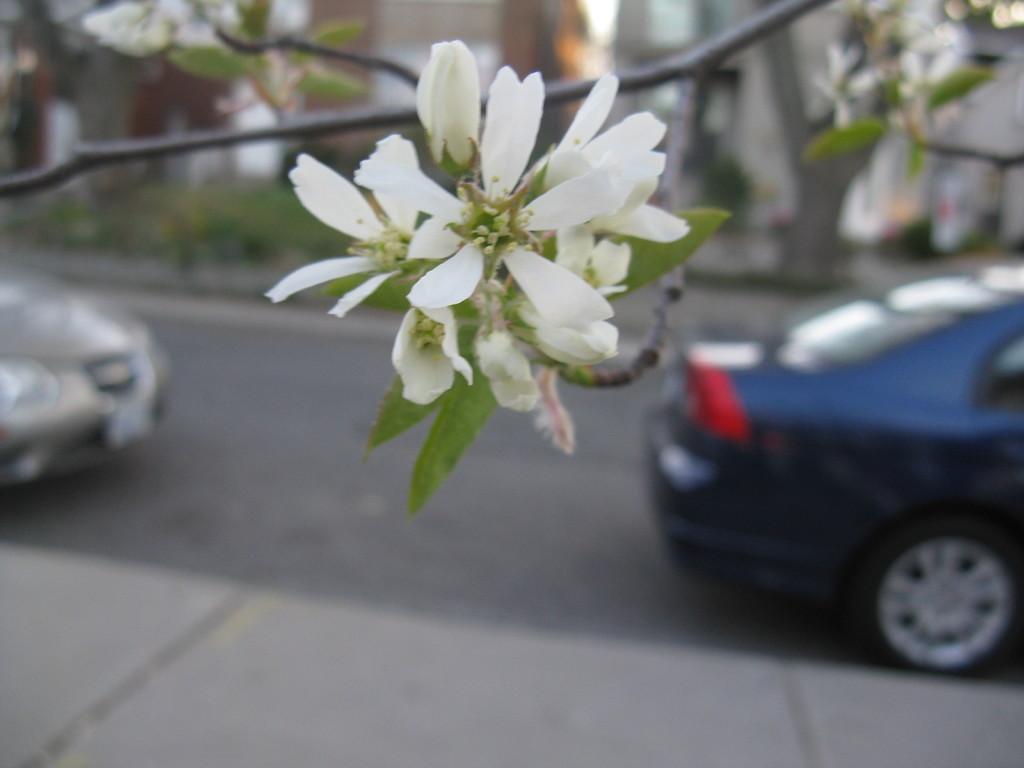In one or two sentences, can you explain what this image depicts? In this picture we can see some flowers on a plant. There are some vehicles visible on the road. There is a building in the background. 